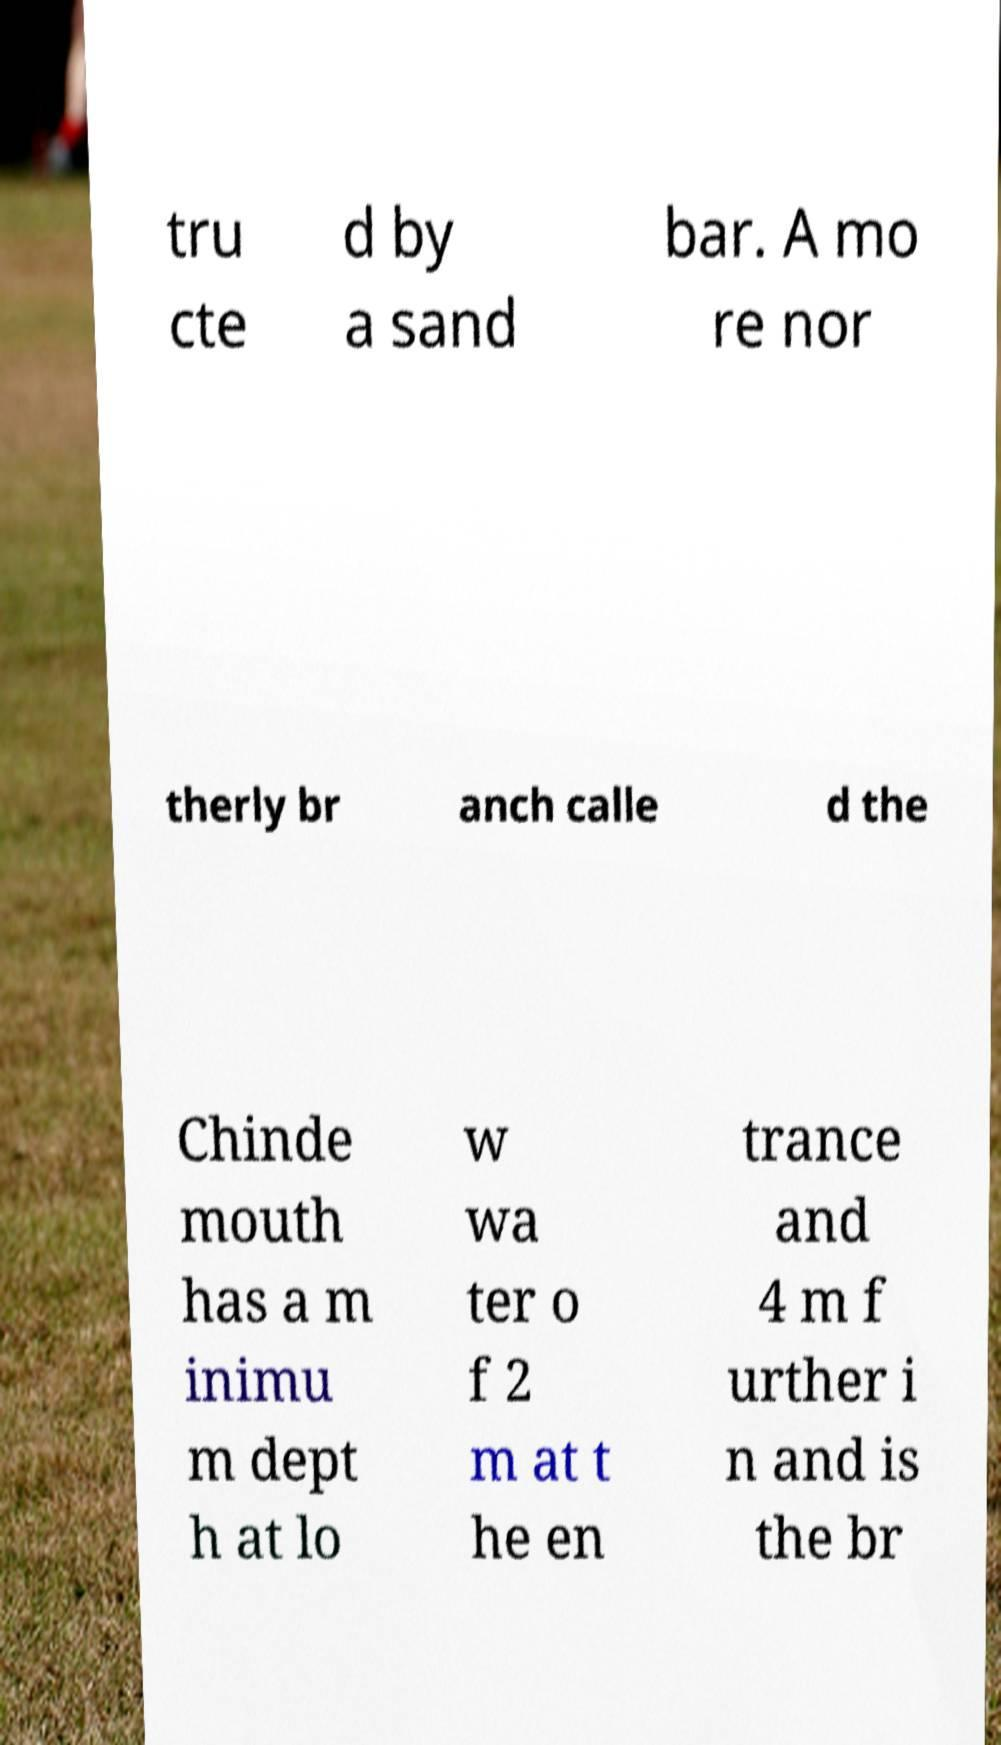I need the written content from this picture converted into text. Can you do that? tru cte d by a sand bar. A mo re nor therly br anch calle d the Chinde mouth has a m inimu m dept h at lo w wa ter o f 2 m at t he en trance and 4 m f urther i n and is the br 